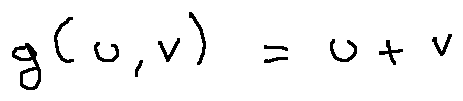Convert formula to latex. <formula><loc_0><loc_0><loc_500><loc_500>g ( u , v ) = u + v</formula> 